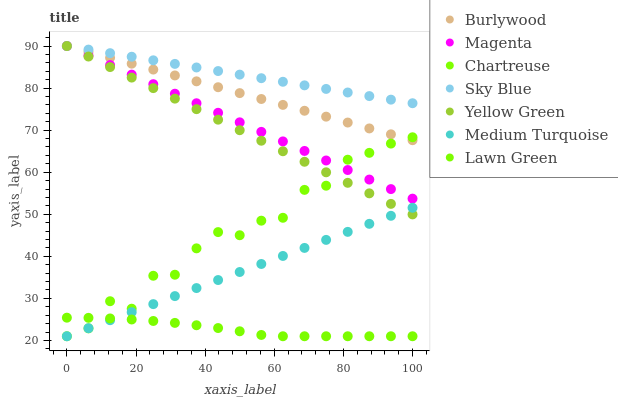Does Lawn Green have the minimum area under the curve?
Answer yes or no. Yes. Does Sky Blue have the maximum area under the curve?
Answer yes or no. Yes. Does Yellow Green have the minimum area under the curve?
Answer yes or no. No. Does Yellow Green have the maximum area under the curve?
Answer yes or no. No. Is Medium Turquoise the smoothest?
Answer yes or no. Yes. Is Chartreuse the roughest?
Answer yes or no. Yes. Is Yellow Green the smoothest?
Answer yes or no. No. Is Yellow Green the roughest?
Answer yes or no. No. Does Lawn Green have the lowest value?
Answer yes or no. Yes. Does Yellow Green have the lowest value?
Answer yes or no. No. Does Magenta have the highest value?
Answer yes or no. Yes. Does Chartreuse have the highest value?
Answer yes or no. No. Is Medium Turquoise less than Burlywood?
Answer yes or no. Yes. Is Burlywood greater than Lawn Green?
Answer yes or no. Yes. Does Yellow Green intersect Sky Blue?
Answer yes or no. Yes. Is Yellow Green less than Sky Blue?
Answer yes or no. No. Is Yellow Green greater than Sky Blue?
Answer yes or no. No. Does Medium Turquoise intersect Burlywood?
Answer yes or no. No. 